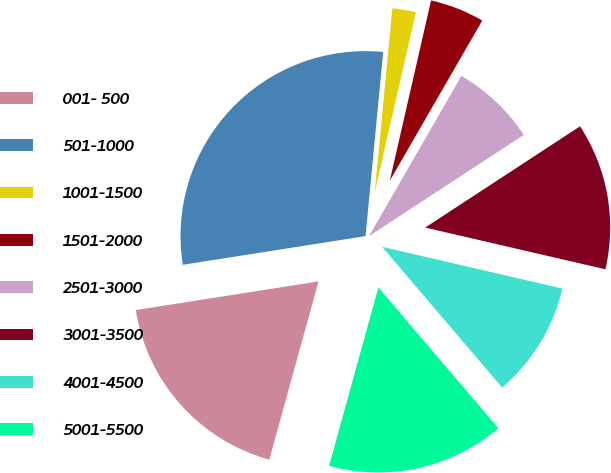Convert chart. <chart><loc_0><loc_0><loc_500><loc_500><pie_chart><fcel>001- 500<fcel>501-1000<fcel>1001-1500<fcel>1501-2000<fcel>2501-3000<fcel>3001-3500<fcel>4001-4500<fcel>5001-5500<nl><fcel>18.23%<fcel>29.0%<fcel>2.06%<fcel>4.75%<fcel>7.45%<fcel>12.84%<fcel>10.14%<fcel>15.53%<nl></chart> 